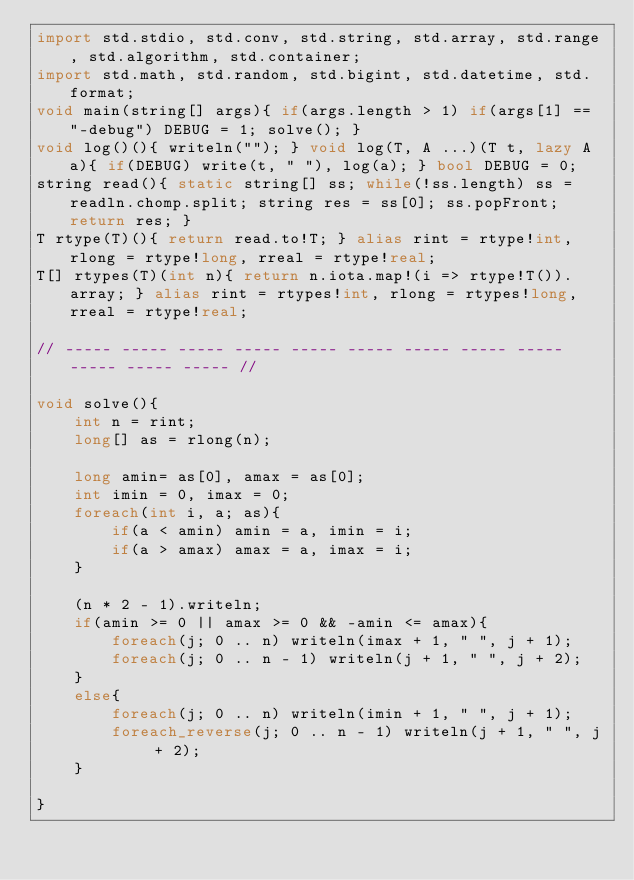Convert code to text. <code><loc_0><loc_0><loc_500><loc_500><_D_>import std.stdio, std.conv, std.string, std.array, std.range, std.algorithm, std.container;
import std.math, std.random, std.bigint, std.datetime, std.format;
void main(string[] args){ if(args.length > 1) if(args[1] == "-debug") DEBUG = 1; solve(); }
void log()(){ writeln(""); } void log(T, A ...)(T t, lazy A a){ if(DEBUG) write(t, " "), log(a); } bool DEBUG = 0; 
string read(){ static string[] ss; while(!ss.length) ss = readln.chomp.split; string res = ss[0]; ss.popFront; return res; }
T rtype(T)(){ return read.to!T; } alias rint = rtype!int, rlong = rtype!long, rreal = rtype!real;
T[] rtypes(T)(int n){ return n.iota.map!(i => rtype!T()).array; } alias rint = rtypes!int, rlong = rtypes!long, rreal = rtype!real;

// ----- ----- ----- ----- ----- ----- ----- ----- ----- ----- ----- ----- //

void solve(){
	int n = rint;
	long[] as = rlong(n);
	
	long amin= as[0], amax = as[0];
	int imin = 0, imax = 0;
	foreach(int i, a; as){
		if(a < amin) amin = a, imin = i;
		if(a > amax) amax = a, imax = i;
	}
	
	(n * 2 - 1).writeln;
	if(amin >= 0 || amax >= 0 && -amin <= amax){
		foreach(j; 0 .. n) writeln(imax + 1, " ", j + 1);
		foreach(j; 0 .. n - 1) writeln(j + 1, " ", j + 2);
	}
	else{
		foreach(j; 0 .. n) writeln(imin + 1, " ", j + 1);
		foreach_reverse(j; 0 .. n - 1) writeln(j + 1, " ", j + 2);
	}
	
}
</code> 